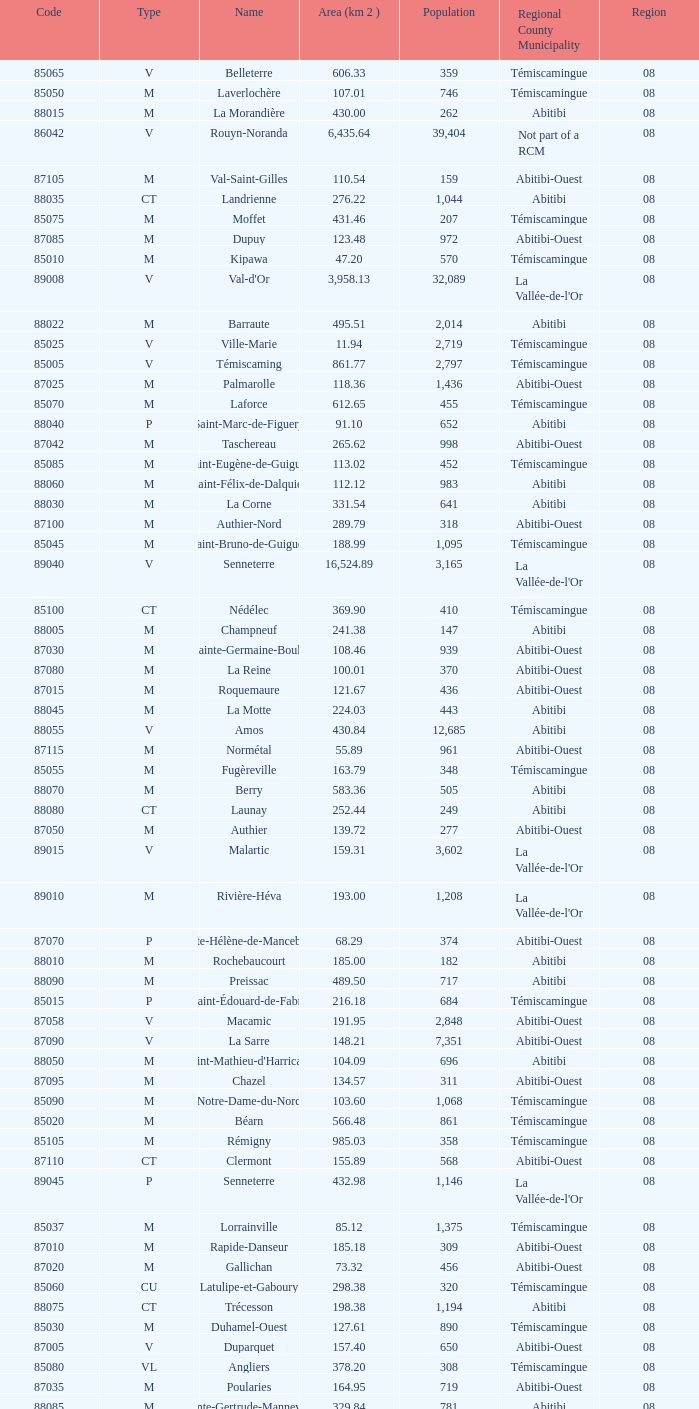What is the km2 area for the population of 311? 134.57. 